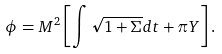Convert formula to latex. <formula><loc_0><loc_0><loc_500><loc_500>\phi = M ^ { 2 } \left [ \int \sqrt { 1 + \Sigma } d t + \pi Y \right ] .</formula> 